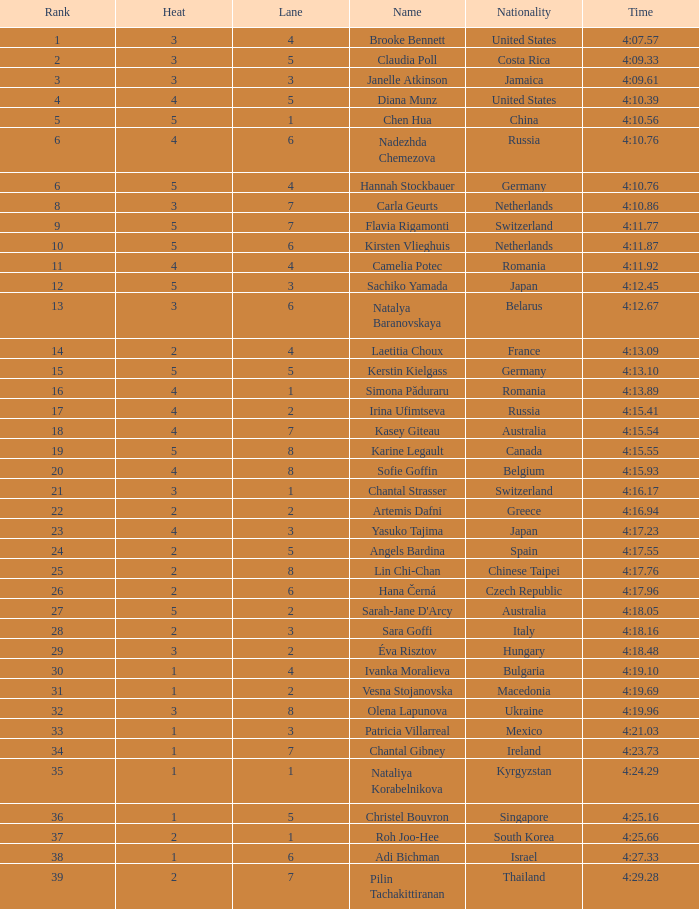Identify the overall quantity of lanes for brooke bennett with a ranking below 0.0. 